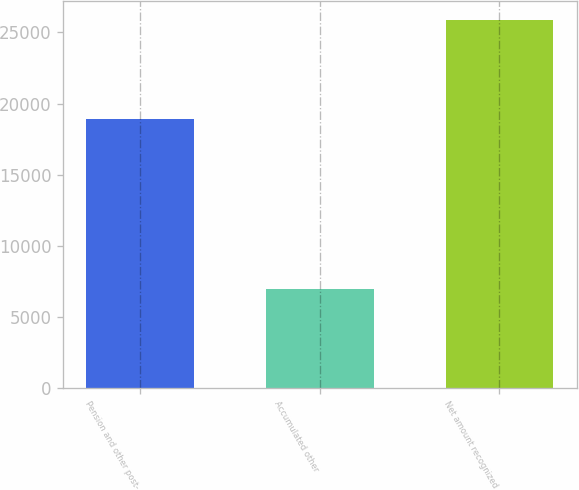<chart> <loc_0><loc_0><loc_500><loc_500><bar_chart><fcel>Pension and other post-<fcel>Accumulated other<fcel>Net amount recognized<nl><fcel>18903<fcel>6983<fcel>25886<nl></chart> 